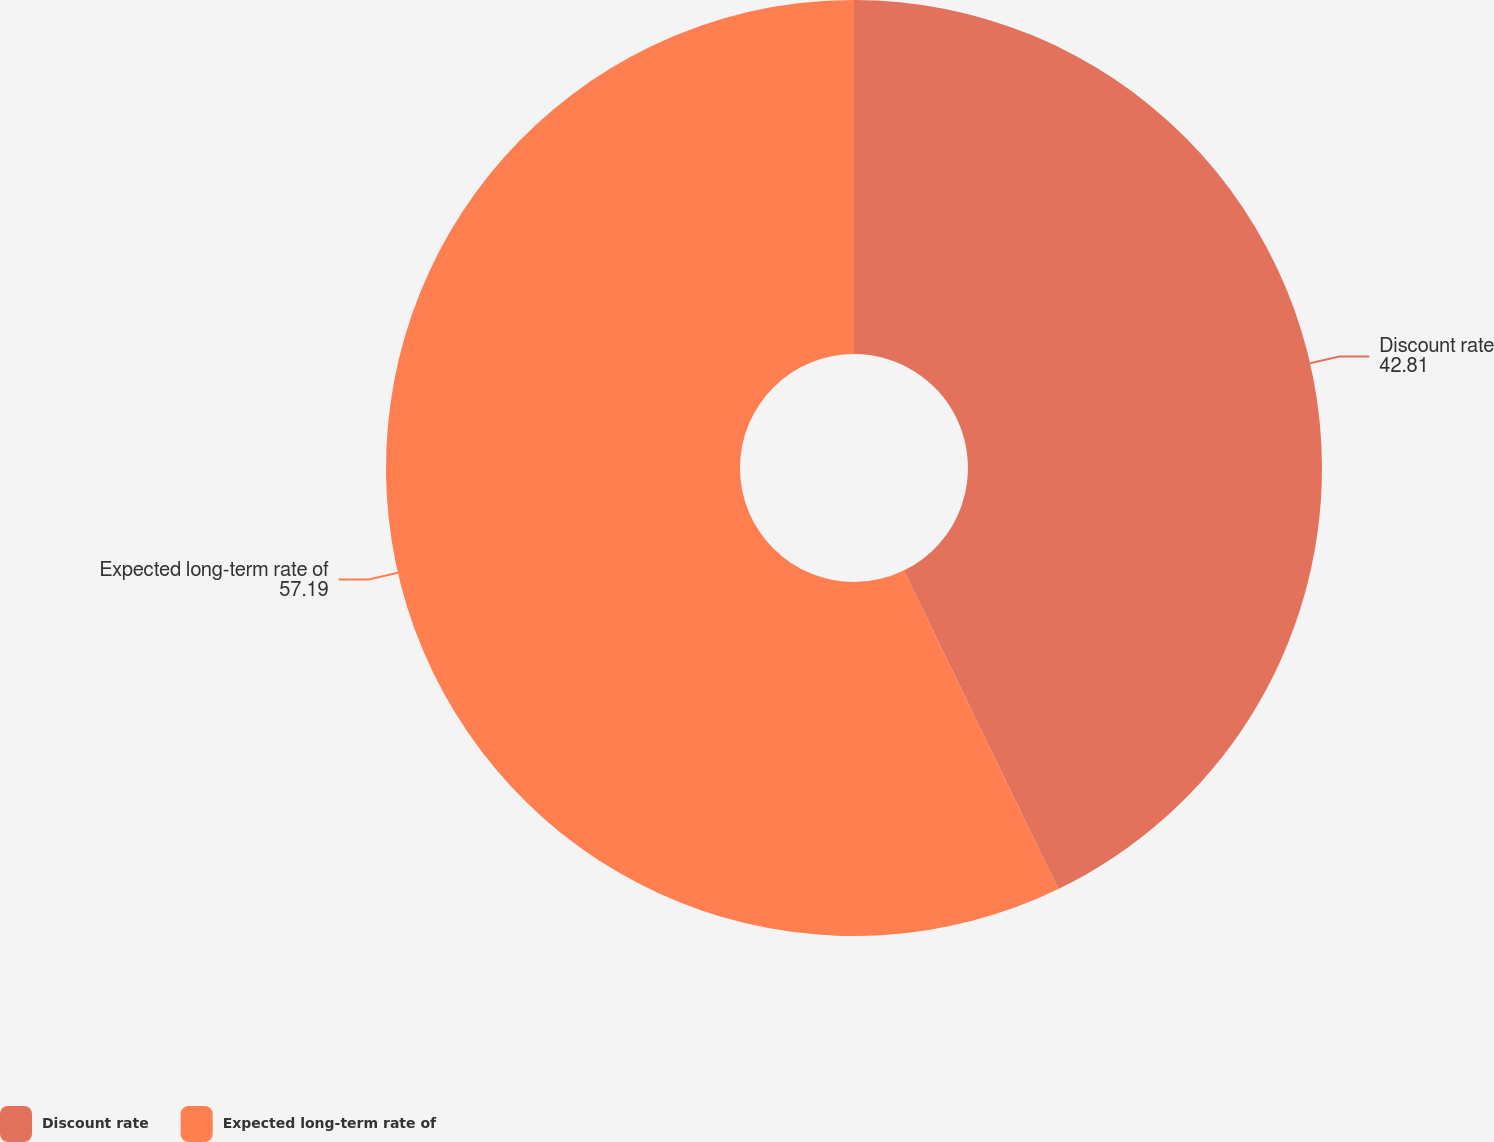<chart> <loc_0><loc_0><loc_500><loc_500><pie_chart><fcel>Discount rate<fcel>Expected long-term rate of<nl><fcel>42.81%<fcel>57.19%<nl></chart> 